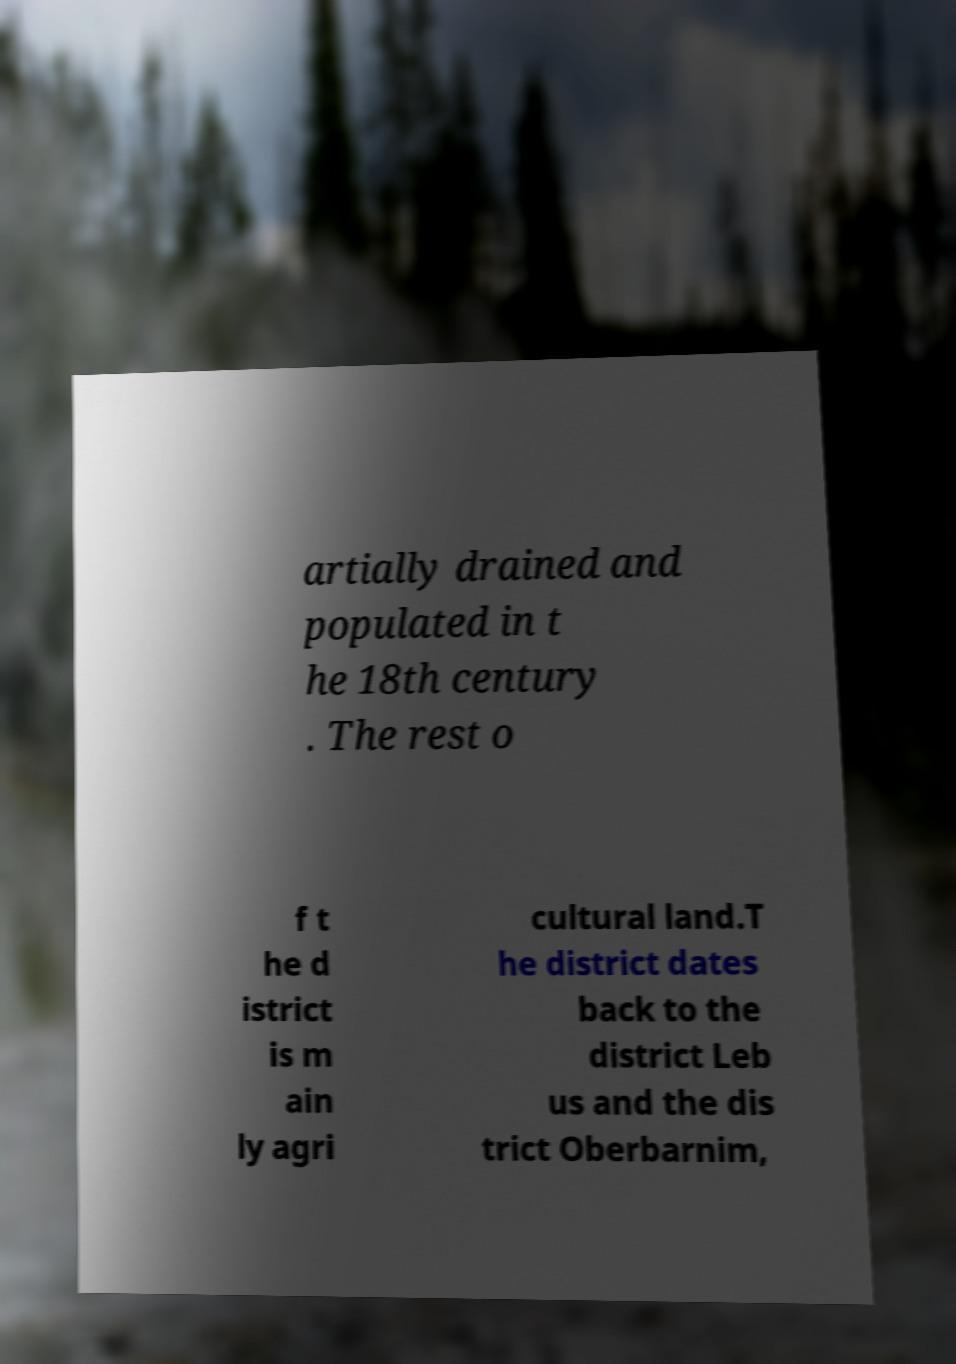Could you extract and type out the text from this image? artially drained and populated in t he 18th century . The rest o f t he d istrict is m ain ly agri cultural land.T he district dates back to the district Leb us and the dis trict Oberbarnim, 